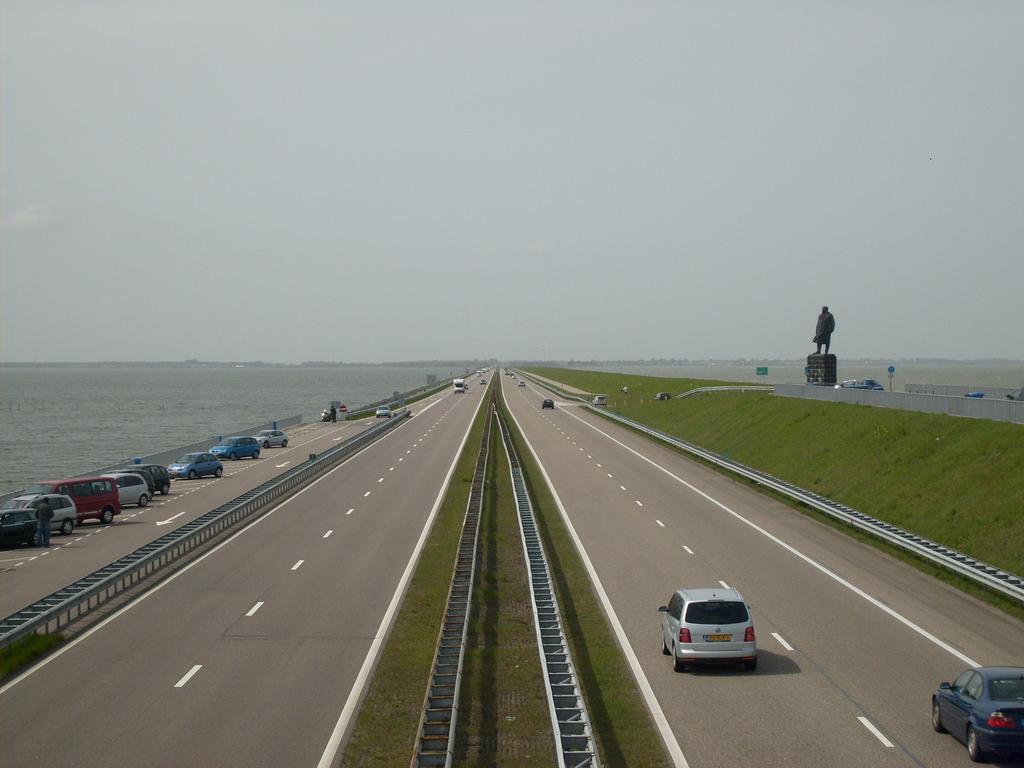Could you give a brief overview of what you see in this image? As we can see in the image there is grass, water, cars, statue and at the top there is sky. 